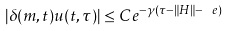<formula> <loc_0><loc_0><loc_500><loc_500>| \delta ( m , t ) u ( t , \tau ) | \leq C e ^ { - \gamma ( \tau - \| H \| - \ e ) } \,</formula> 